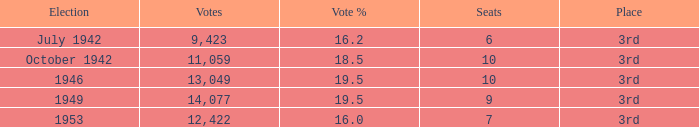Identify the combined percentage of votes that is greater than 19.5%. None. 